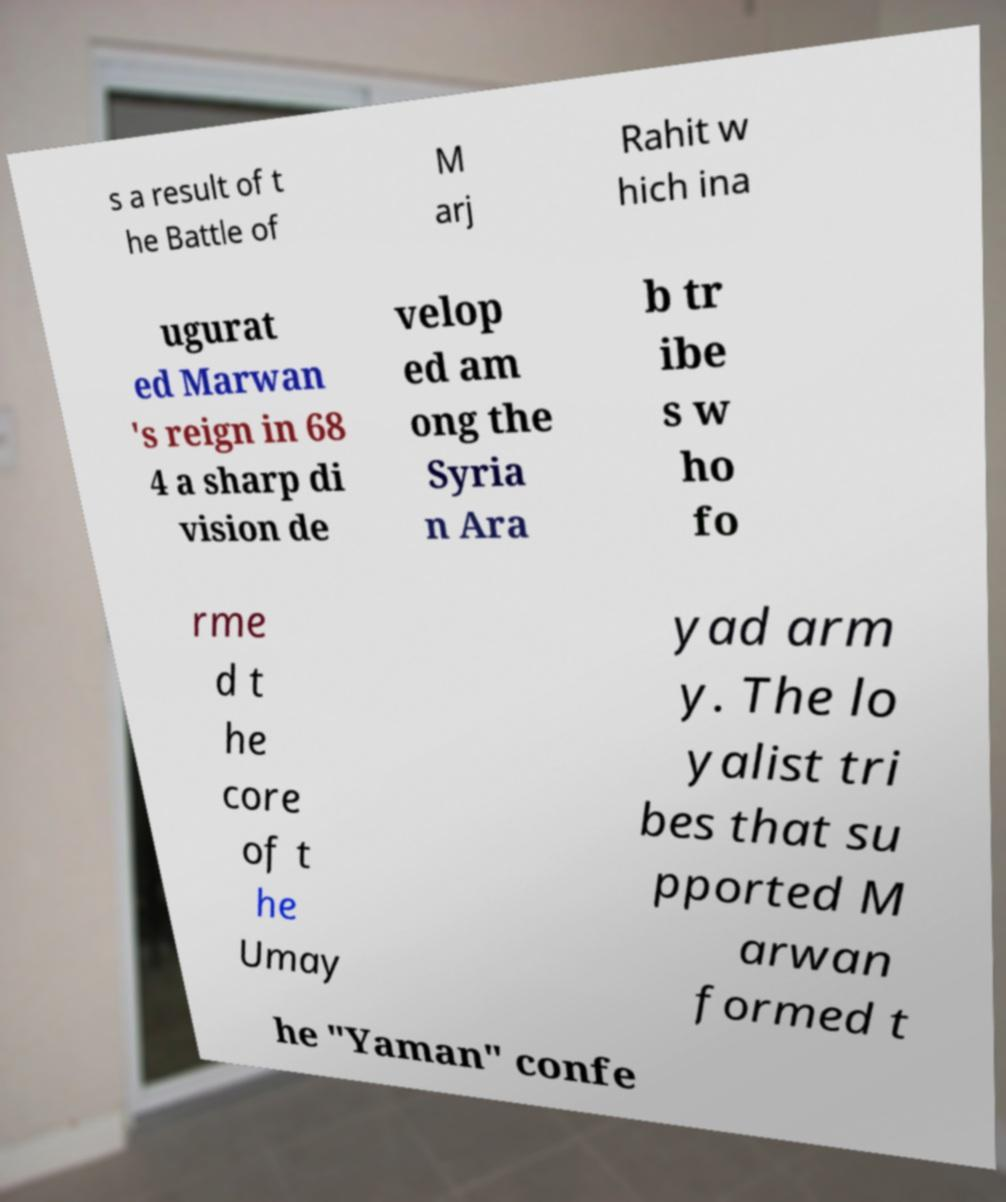Could you extract and type out the text from this image? s a result of t he Battle of M arj Rahit w hich ina ugurat ed Marwan 's reign in 68 4 a sharp di vision de velop ed am ong the Syria n Ara b tr ibe s w ho fo rme d t he core of t he Umay yad arm y. The lo yalist tri bes that su pported M arwan formed t he "Yaman" confe 